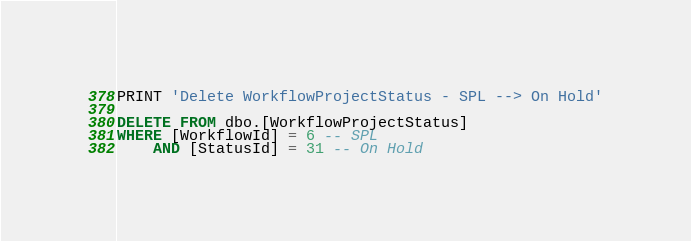<code> <loc_0><loc_0><loc_500><loc_500><_SQL_>PRINT 'Delete WorkflowProjectStatus - SPL --> On Hold'

DELETE FROM dbo.[WorkflowProjectStatus]
WHERE [WorkflowId] = 6 -- SPL
    AND [StatusId] = 31 -- On Hold
</code> 